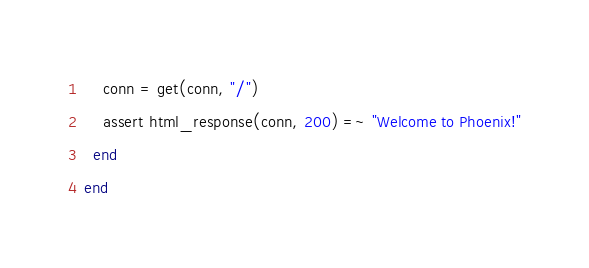<code> <loc_0><loc_0><loc_500><loc_500><_Elixir_>    conn = get(conn, "/")
    assert html_response(conn, 200) =~ "Welcome to Phoenix!"
  end
end
</code> 